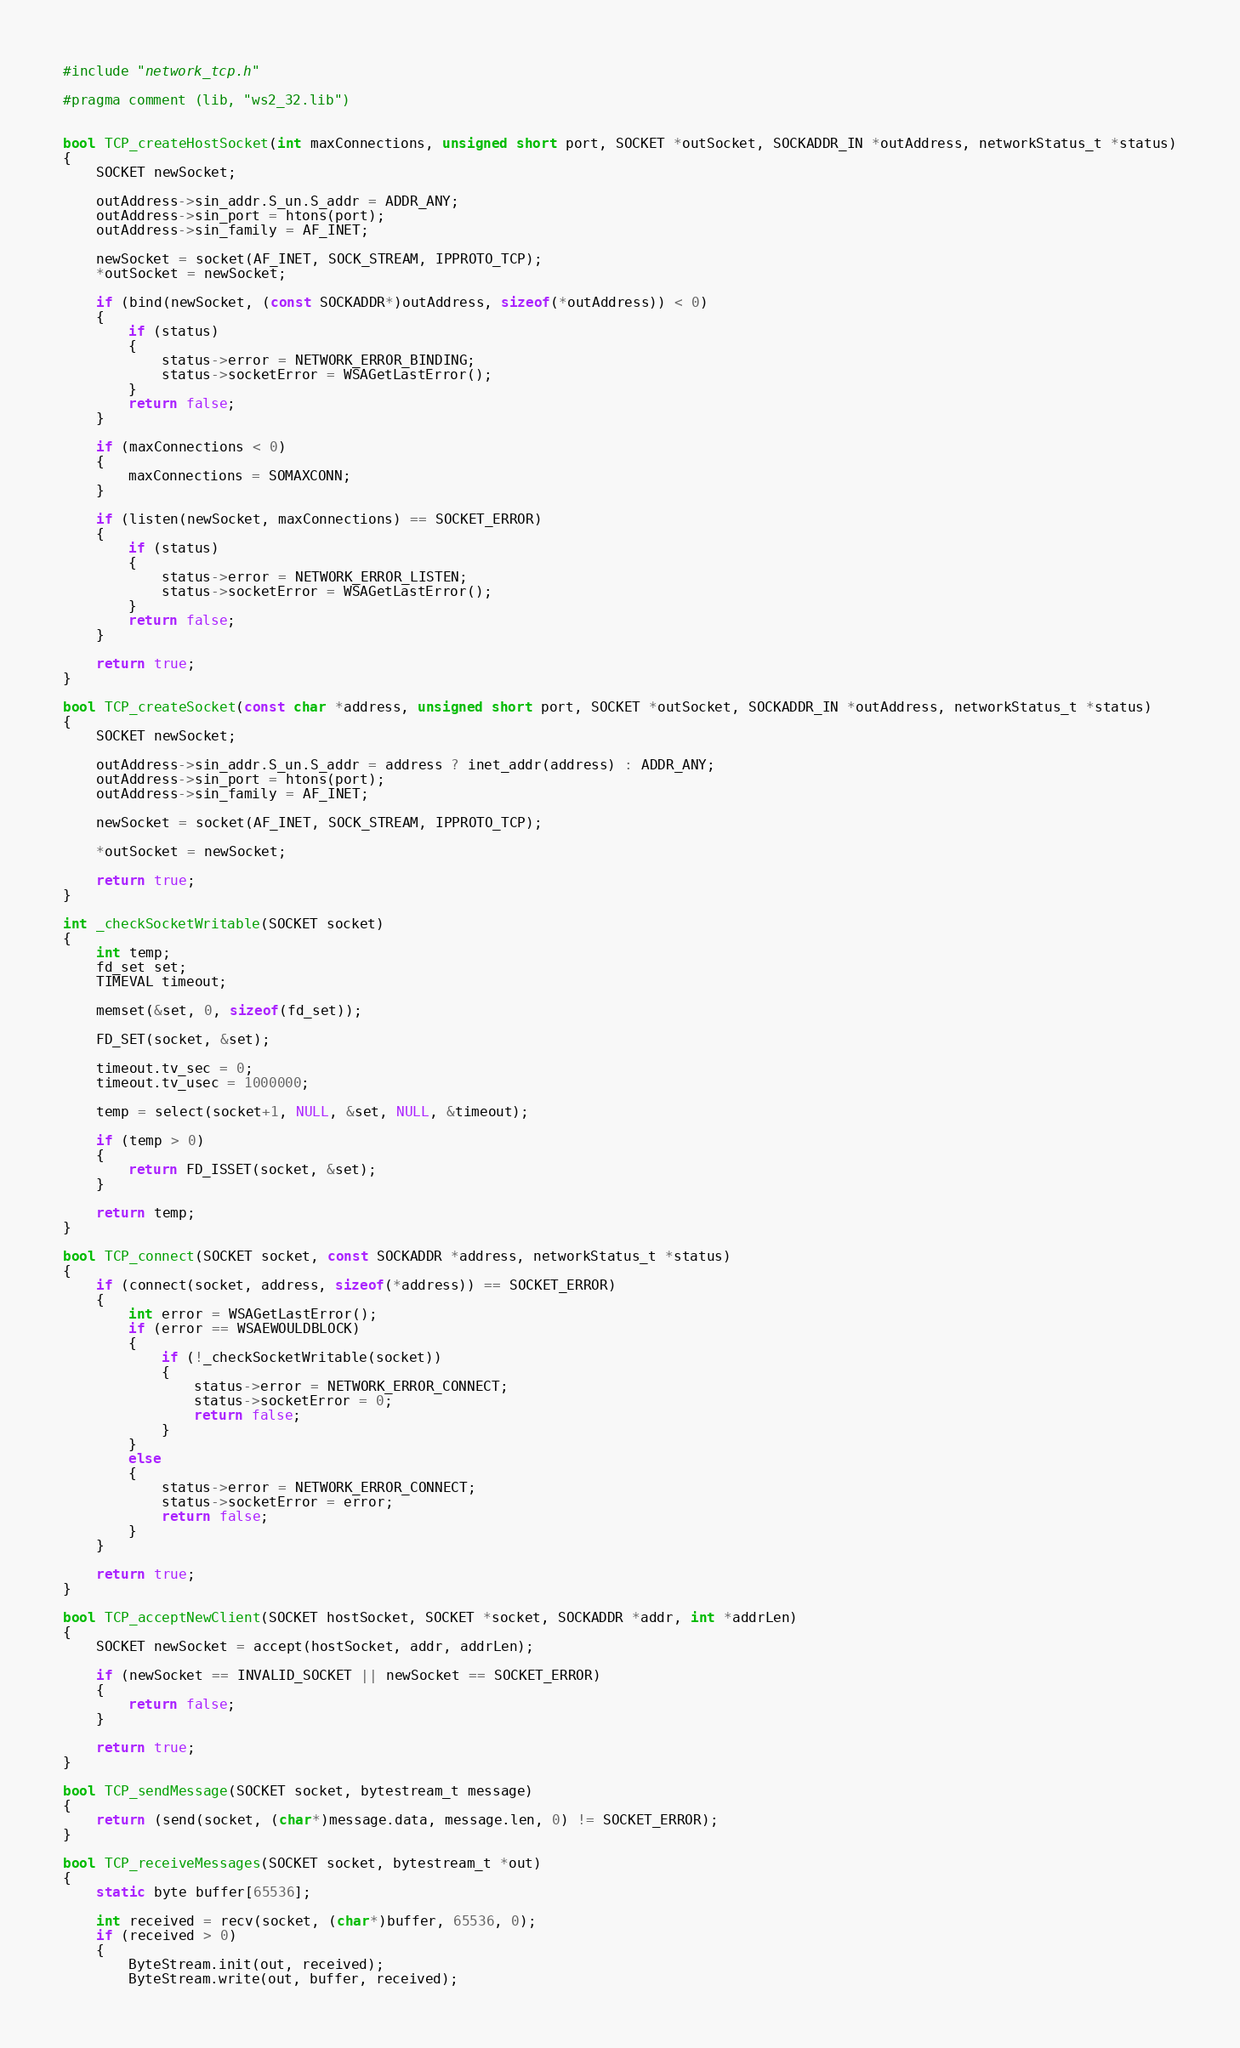<code> <loc_0><loc_0><loc_500><loc_500><_C_>#include "network_tcp.h"

#pragma comment (lib, "ws2_32.lib")


bool TCP_createHostSocket(int maxConnections, unsigned short port, SOCKET *outSocket, SOCKADDR_IN *outAddress, networkStatus_t *status)
{
	SOCKET newSocket;

	outAddress->sin_addr.S_un.S_addr = ADDR_ANY;
	outAddress->sin_port = htons(port);
	outAddress->sin_family = AF_INET;

	newSocket = socket(AF_INET, SOCK_STREAM, IPPROTO_TCP);
	*outSocket = newSocket;

	if (bind(newSocket, (const SOCKADDR*)outAddress, sizeof(*outAddress)) < 0)
	{
		if (status)
		{
			status->error = NETWORK_ERROR_BINDING;
			status->socketError = WSAGetLastError();
		}
		return false;
	}

	if (maxConnections < 0)
	{
		maxConnections = SOMAXCONN;
	}

	if (listen(newSocket, maxConnections) == SOCKET_ERROR)
	{
		if (status)
		{
			status->error = NETWORK_ERROR_LISTEN;
			status->socketError = WSAGetLastError();
		}
		return false;
	}

	return true;
}

bool TCP_createSocket(const char *address, unsigned short port, SOCKET *outSocket, SOCKADDR_IN *outAddress, networkStatus_t *status)
{
	SOCKET newSocket;

	outAddress->sin_addr.S_un.S_addr = address ? inet_addr(address) : ADDR_ANY;
	outAddress->sin_port = htons(port);
	outAddress->sin_family = AF_INET;

	newSocket = socket(AF_INET, SOCK_STREAM, IPPROTO_TCP);

	*outSocket = newSocket;

	return true;
}

int _checkSocketWritable(SOCKET socket)
{
	int temp;
	fd_set set;
	TIMEVAL timeout;

	memset(&set, 0, sizeof(fd_set));

	FD_SET(socket, &set);

	timeout.tv_sec = 0;
	timeout.tv_usec = 1000000;

	temp = select(socket+1, NULL, &set, NULL, &timeout);
	
	if (temp > 0)
	{
		return FD_ISSET(socket, &set);
	}
	
	return temp;
}

bool TCP_connect(SOCKET socket, const SOCKADDR *address, networkStatus_t *status)
{
	if (connect(socket, address, sizeof(*address)) == SOCKET_ERROR)
	{
		int error = WSAGetLastError();
		if (error == WSAEWOULDBLOCK)
		{
			if (!_checkSocketWritable(socket))
			{
				status->error = NETWORK_ERROR_CONNECT;
				status->socketError = 0;
				return false;
			}
		}
		else
		{
			status->error = NETWORK_ERROR_CONNECT;
			status->socketError = error;
			return false;
		}
	}

	return true;
}

bool TCP_acceptNewClient(SOCKET hostSocket, SOCKET *socket, SOCKADDR *addr, int *addrLen)
{
	SOCKET newSocket = accept(hostSocket, addr, addrLen);
	
	if (newSocket == INVALID_SOCKET || newSocket == SOCKET_ERROR)
	{
		return false;
	}

	return true;
}

bool TCP_sendMessage(SOCKET socket, bytestream_t message)
{
	return (send(socket, (char*)message.data, message.len, 0) != SOCKET_ERROR);
}

bool TCP_receiveMessages(SOCKET socket, bytestream_t *out)
{
	static byte buffer[65536];
	
	int received = recv(socket, (char*)buffer, 65536, 0);
	if (received > 0)
	{
		ByteStream.init(out, received);
		ByteStream.write(out, buffer, received);</code> 